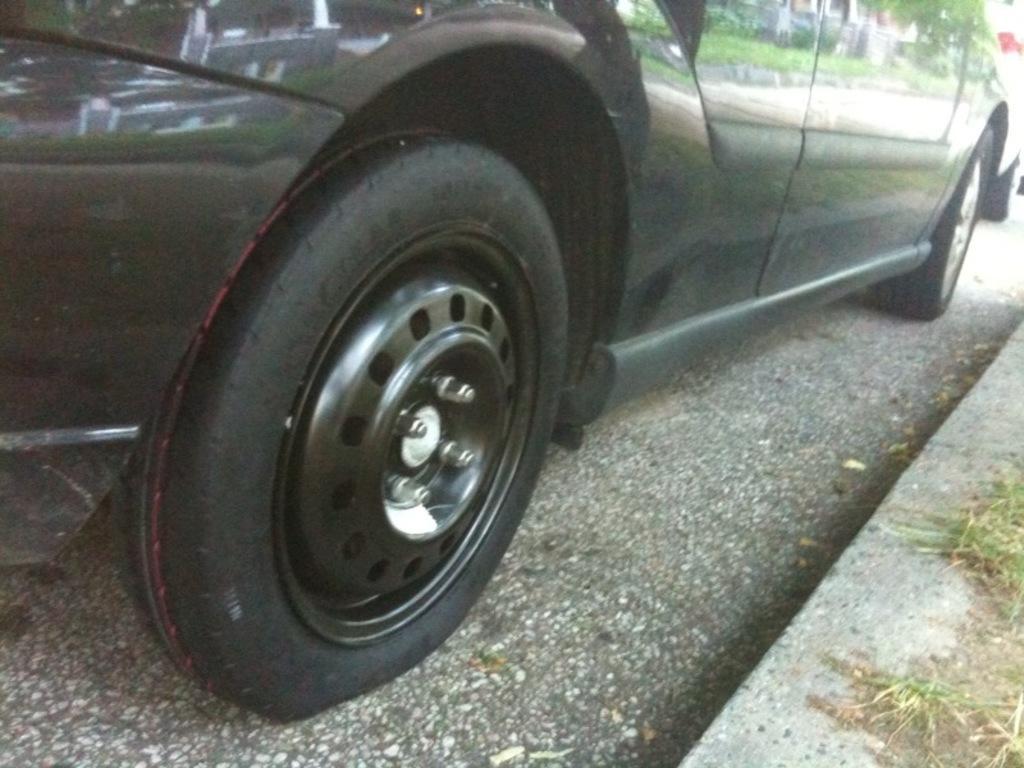How would you summarize this image in a sentence or two? In this picture we can see a vehicle on the road. On the vehicle, we can see the reflection of grass, a tree and a building. 